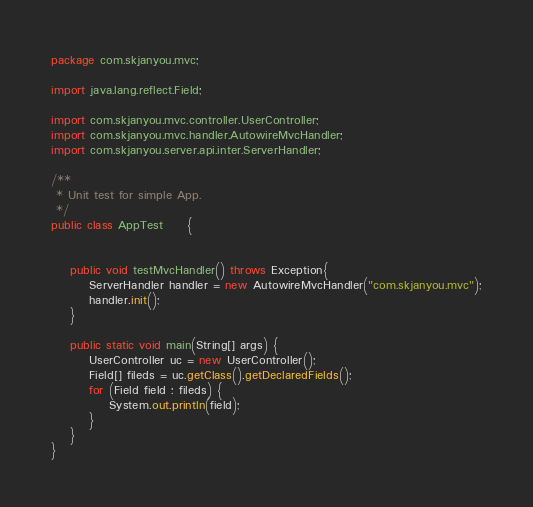Convert code to text. <code><loc_0><loc_0><loc_500><loc_500><_Java_>package com.skjanyou.mvc;

import java.lang.reflect.Field;

import com.skjanyou.mvc.controller.UserController;
import com.skjanyou.mvc.handler.AutowireMvcHandler;
import com.skjanyou.server.api.inter.ServerHandler;

/**
 * Unit test for simple App.
 */
public class AppTest 	 {


    public void testMvcHandler() throws Exception{
    	ServerHandler handler = new AutowireMvcHandler("com.skjanyou.mvc");
    	handler.init();
    }
    
    public static void main(String[] args) {
		UserController uc = new UserController();
		Field[] fileds = uc.getClass().getDeclaredFields();
		for (Field field : fileds) {
			System.out.println(field);
		}
	}
}
</code> 